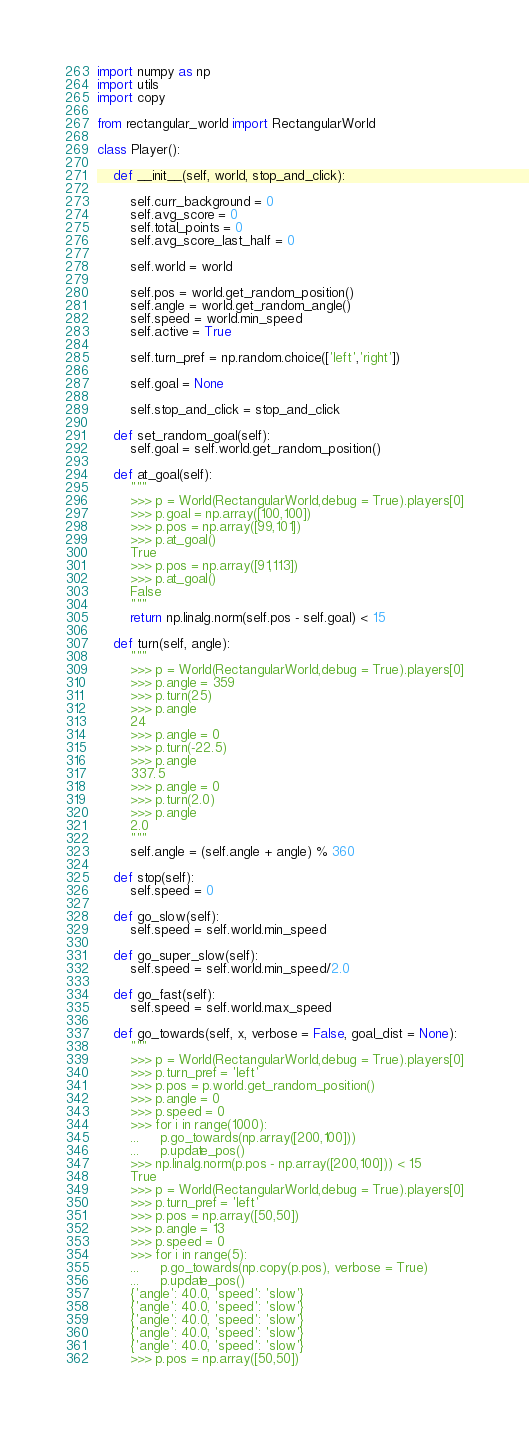Convert code to text. <code><loc_0><loc_0><loc_500><loc_500><_Python_>
import numpy as np
import utils
import copy

from rectangular_world import RectangularWorld

class Player():

    def __init__(self, world, stop_and_click):

        self.curr_background = 0
        self.avg_score = 0
        self.total_points = 0
        self.avg_score_last_half = 0

        self.world = world
                
        self.pos = world.get_random_position()
        self.angle = world.get_random_angle()
        self.speed = world.min_speed
        self.active = True

        self.turn_pref = np.random.choice(['left','right'])

        self.goal = None

        self.stop_and_click = stop_and_click

    def set_random_goal(self):
        self.goal = self.world.get_random_position()
    
    def at_goal(self):
        """
        >>> p = World(RectangularWorld,debug = True).players[0]
        >>> p.goal = np.array([100,100])
        >>> p.pos = np.array([99,101])
        >>> p.at_goal()
        True
        >>> p.pos = np.array([91,113])
        >>> p.at_goal()
        False
        """
        return np.linalg.norm(self.pos - self.goal) < 15
        
    def turn(self, angle):
        """
        >>> p = World(RectangularWorld,debug = True).players[0]
        >>> p.angle = 359
        >>> p.turn(25)
        >>> p.angle
        24
        >>> p.angle = 0
        >>> p.turn(-22.5)
        >>> p.angle
        337.5
        >>> p.angle = 0
        >>> p.turn(2.0)
        >>> p.angle
        2.0
        """
        self.angle = (self.angle + angle) % 360
    
    def stop(self):
        self.speed = 0
        
    def go_slow(self):
        self.speed = self.world.min_speed

    def go_super_slow(self):
        self.speed = self.world.min_speed/2.0
    
    def go_fast(self):
        self.speed = self.world.max_speed

    def go_towards(self, x, verbose = False, goal_dist = None):
        """
        >>> p = World(RectangularWorld,debug = True).players[0]
        >>> p.turn_pref = 'left'
        >>> p.pos = p.world.get_random_position()
        >>> p.angle = 0
        >>> p.speed = 0
        >>> for i in range(1000):
        ...     p.go_towards(np.array([200,100]))
        ...     p.update_pos()
        >>> np.linalg.norm(p.pos - np.array([200,100])) < 15
        True
        >>> p = World(RectangularWorld,debug = True).players[0]
        >>> p.turn_pref = 'left'
        >>> p.pos = np.array([50,50])
        >>> p.angle = 13
        >>> p.speed = 0
        >>> for i in range(5):
        ...     p.go_towards(np.copy(p.pos), verbose = True)
        ...     p.update_pos()
        {'angle': 40.0, 'speed': 'slow'}
        {'angle': 40.0, 'speed': 'slow'}
        {'angle': 40.0, 'speed': 'slow'}
        {'angle': 40.0, 'speed': 'slow'}
        {'angle': 40.0, 'speed': 'slow'}
        >>> p.pos = np.array([50,50])</code> 